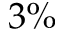Convert formula to latex. <formula><loc_0><loc_0><loc_500><loc_500>3 \%</formula> 